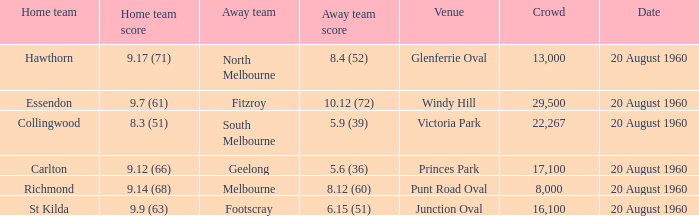Where does the match take place when geelong is not the home team? Princes Park. 